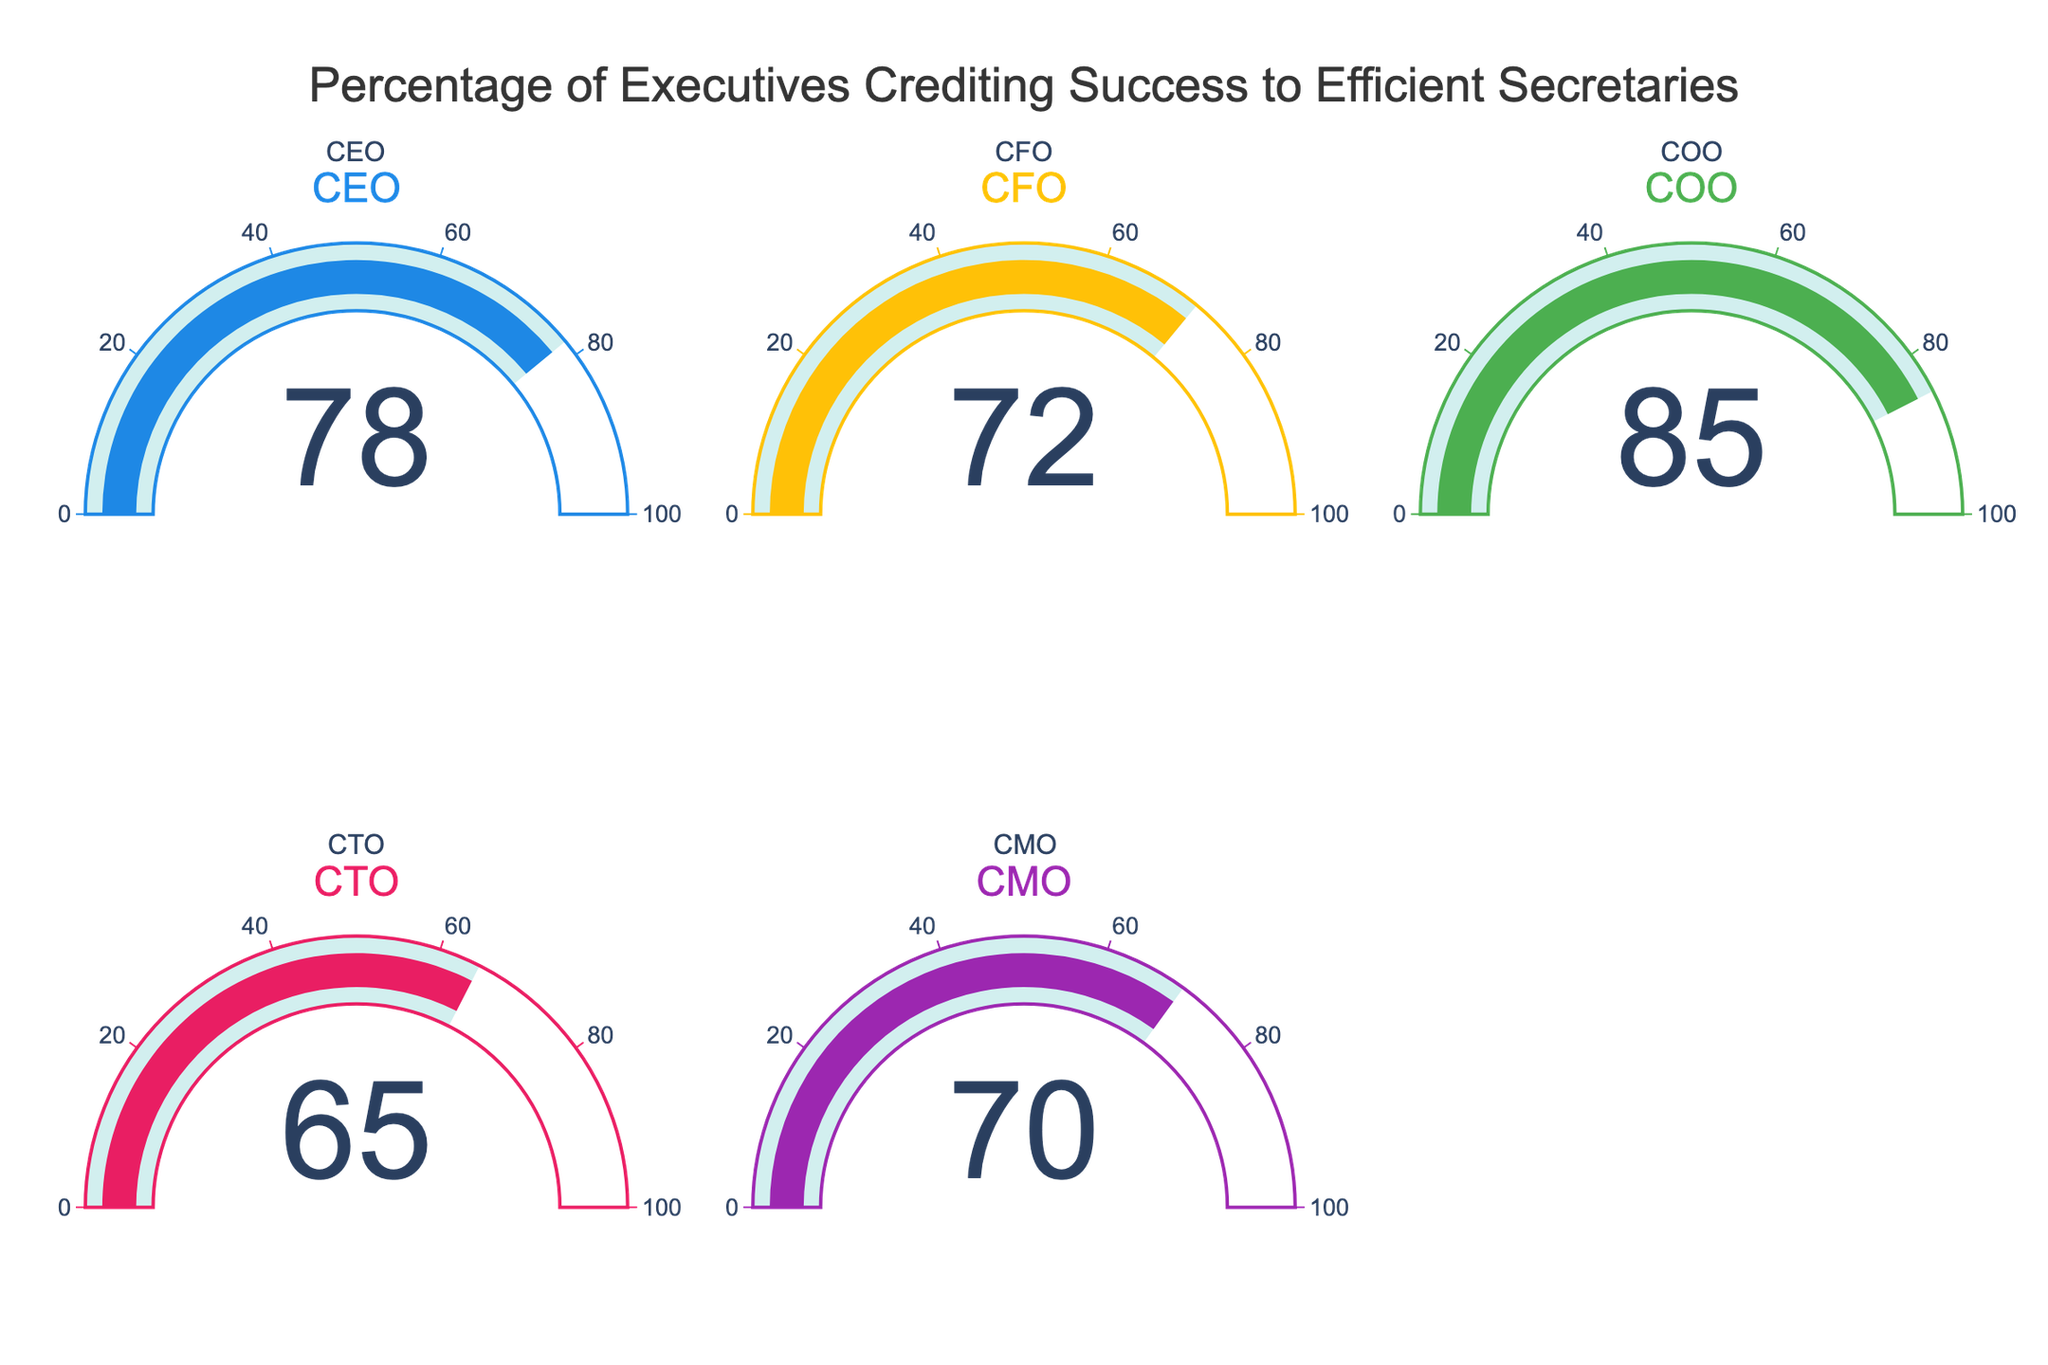what's the percentage of CEOs who credit their success to efficient secretaries? The value shown for CEOs in their gauge is 78.
Answer: 78 What's the lowest percentage shown on the gauges? The lowest percentage is in the gauge for CTO with a value of 65.
Answer: 65 Which executive role has the highest percentage value? The COO gauge has the highest percentage of 85.
Answer: COO Calculate the average percentage of all executives. Add the percentages: 78 (CEO) + 72 (CFO) + 85 (COO) + 65 (CTO) + 70 (CMO) = 370. Then, divide by the number of roles, 370/5 = 74.
Answer: 74 What's the difference between the COO's and CTO's percentages? Subtract the CTO's percentage from the COO's, 85 - 65 = 20.
Answer: 20 How many executive roles have a percentage of 70 or higher? Count the roles with percentages 70 or higher: CEO (78), CFO (72), COO (85), CMO (70). That's 4 roles.
Answer: 4 What is the combined percentage of the CEO and CMO? Add the percentages for the CEO and CMO: 78 + 70 = 148.
Answer: 148 Which executive roles have percentages less than 75? The roles with percentages less than 75 are CFO (72), CTO (65), and CMO (70).
Answer: CFO, CTO, CMO What is the median percentage value displayed in the gauges? The percentages are 78, 72, 85, 65, 70. When ordered: 65, 70, 72, 78, 85. The middle value (median) is 72.
Answer: 72 